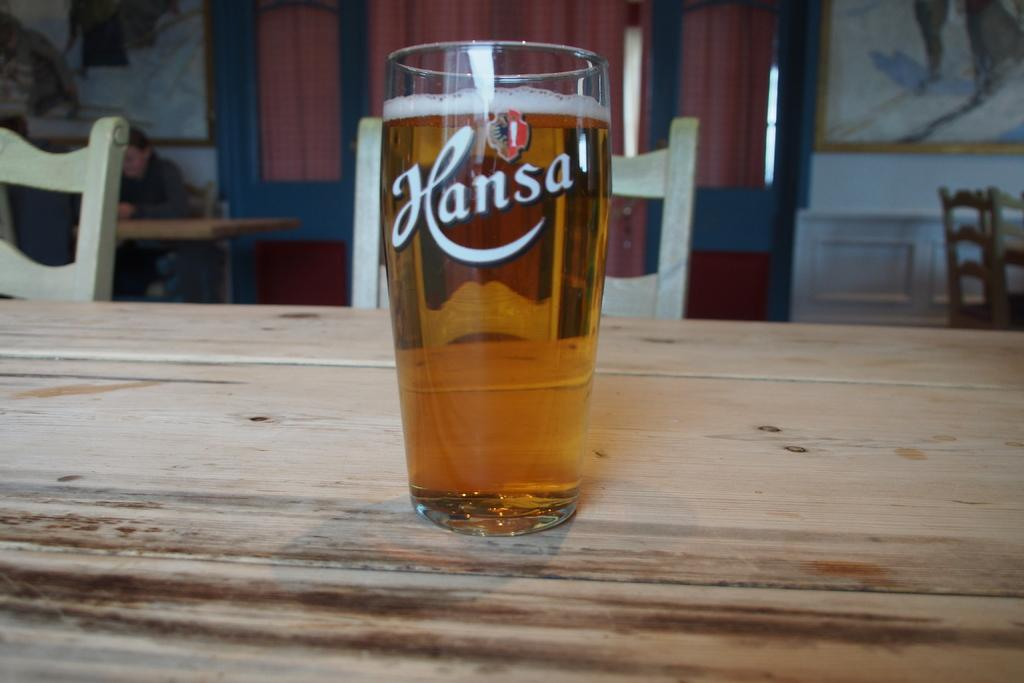What is on the table in the image? There is a glass of wine on the table. Are there any chairs visible in the image? Yes, there are chairs behind the table. What type of acoustics can be heard in the image? There is no information about acoustics in the image, as it only shows a glass of wine on a table and chairs behind it. 